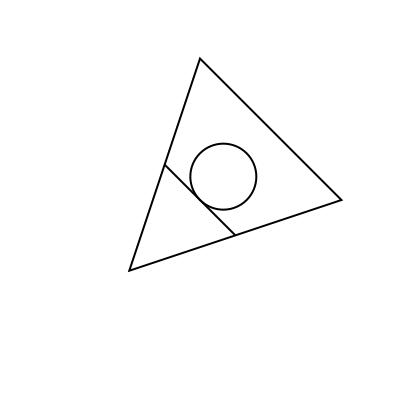Identify the heraldic ordinaries represented in this rotated coat of arms. Which two primary ordinaries are combined to form this unique design? To solve this problem, we need to mentally rotate the image back to its standard orientation and identify the heraldic ordinaries:

1. First, rotate the image 45 degrees counterclockwise in your mind.
2. After rotation, you should see a shield-like shape pointing downwards.
3. The primary shape forming the shield is a triangle, which in heraldry represents the ordinary known as a "pile."
4. Inside the shield, there is a horizontal line crossing the center. This represents the ordinary known as a "fess."
5. The circle in the upper part of the shield is not one of the primary ordinaries but rather a subordinary called a "roundel."

The two primary ordinaries combined in this design are the pile (the triangular shape of the shield) and the fess (the horizontal line).
Answer: Pile and Fess 